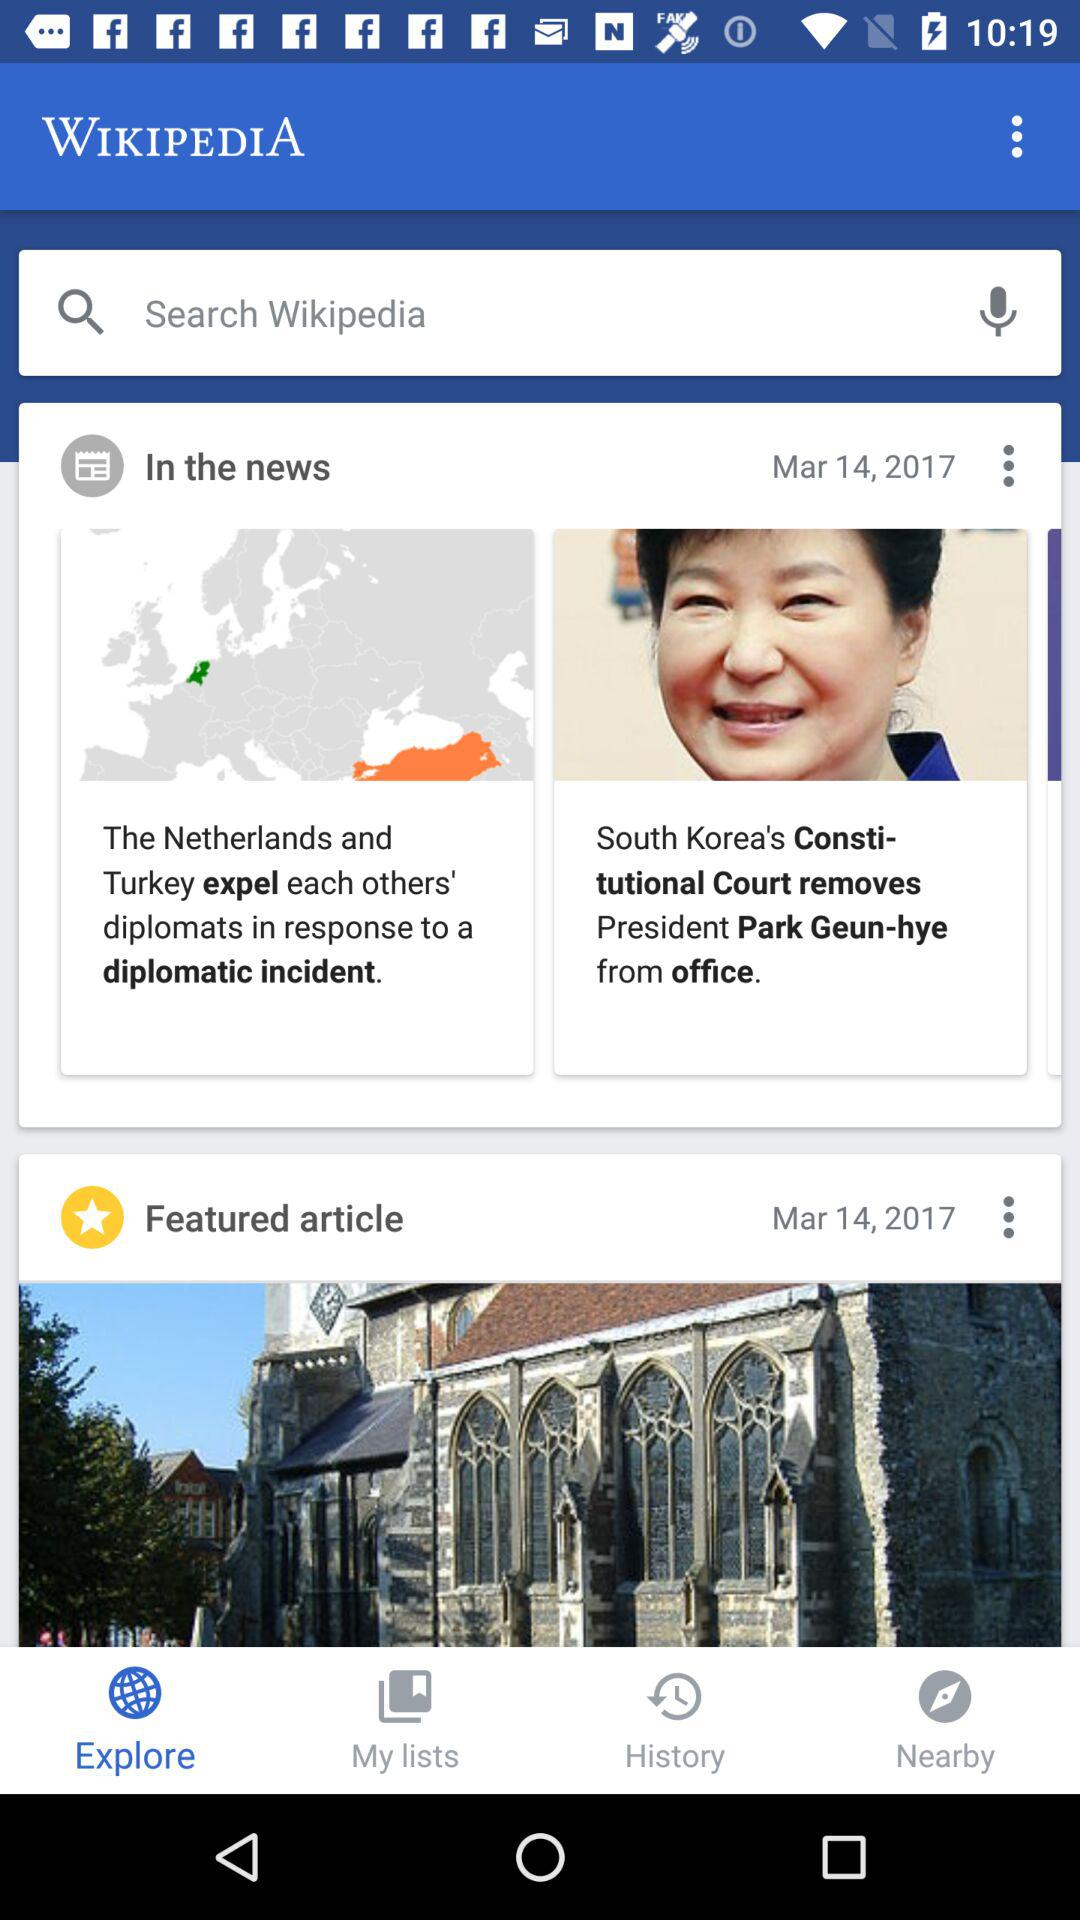Which tab is selected? The selected tab is "Explore". 